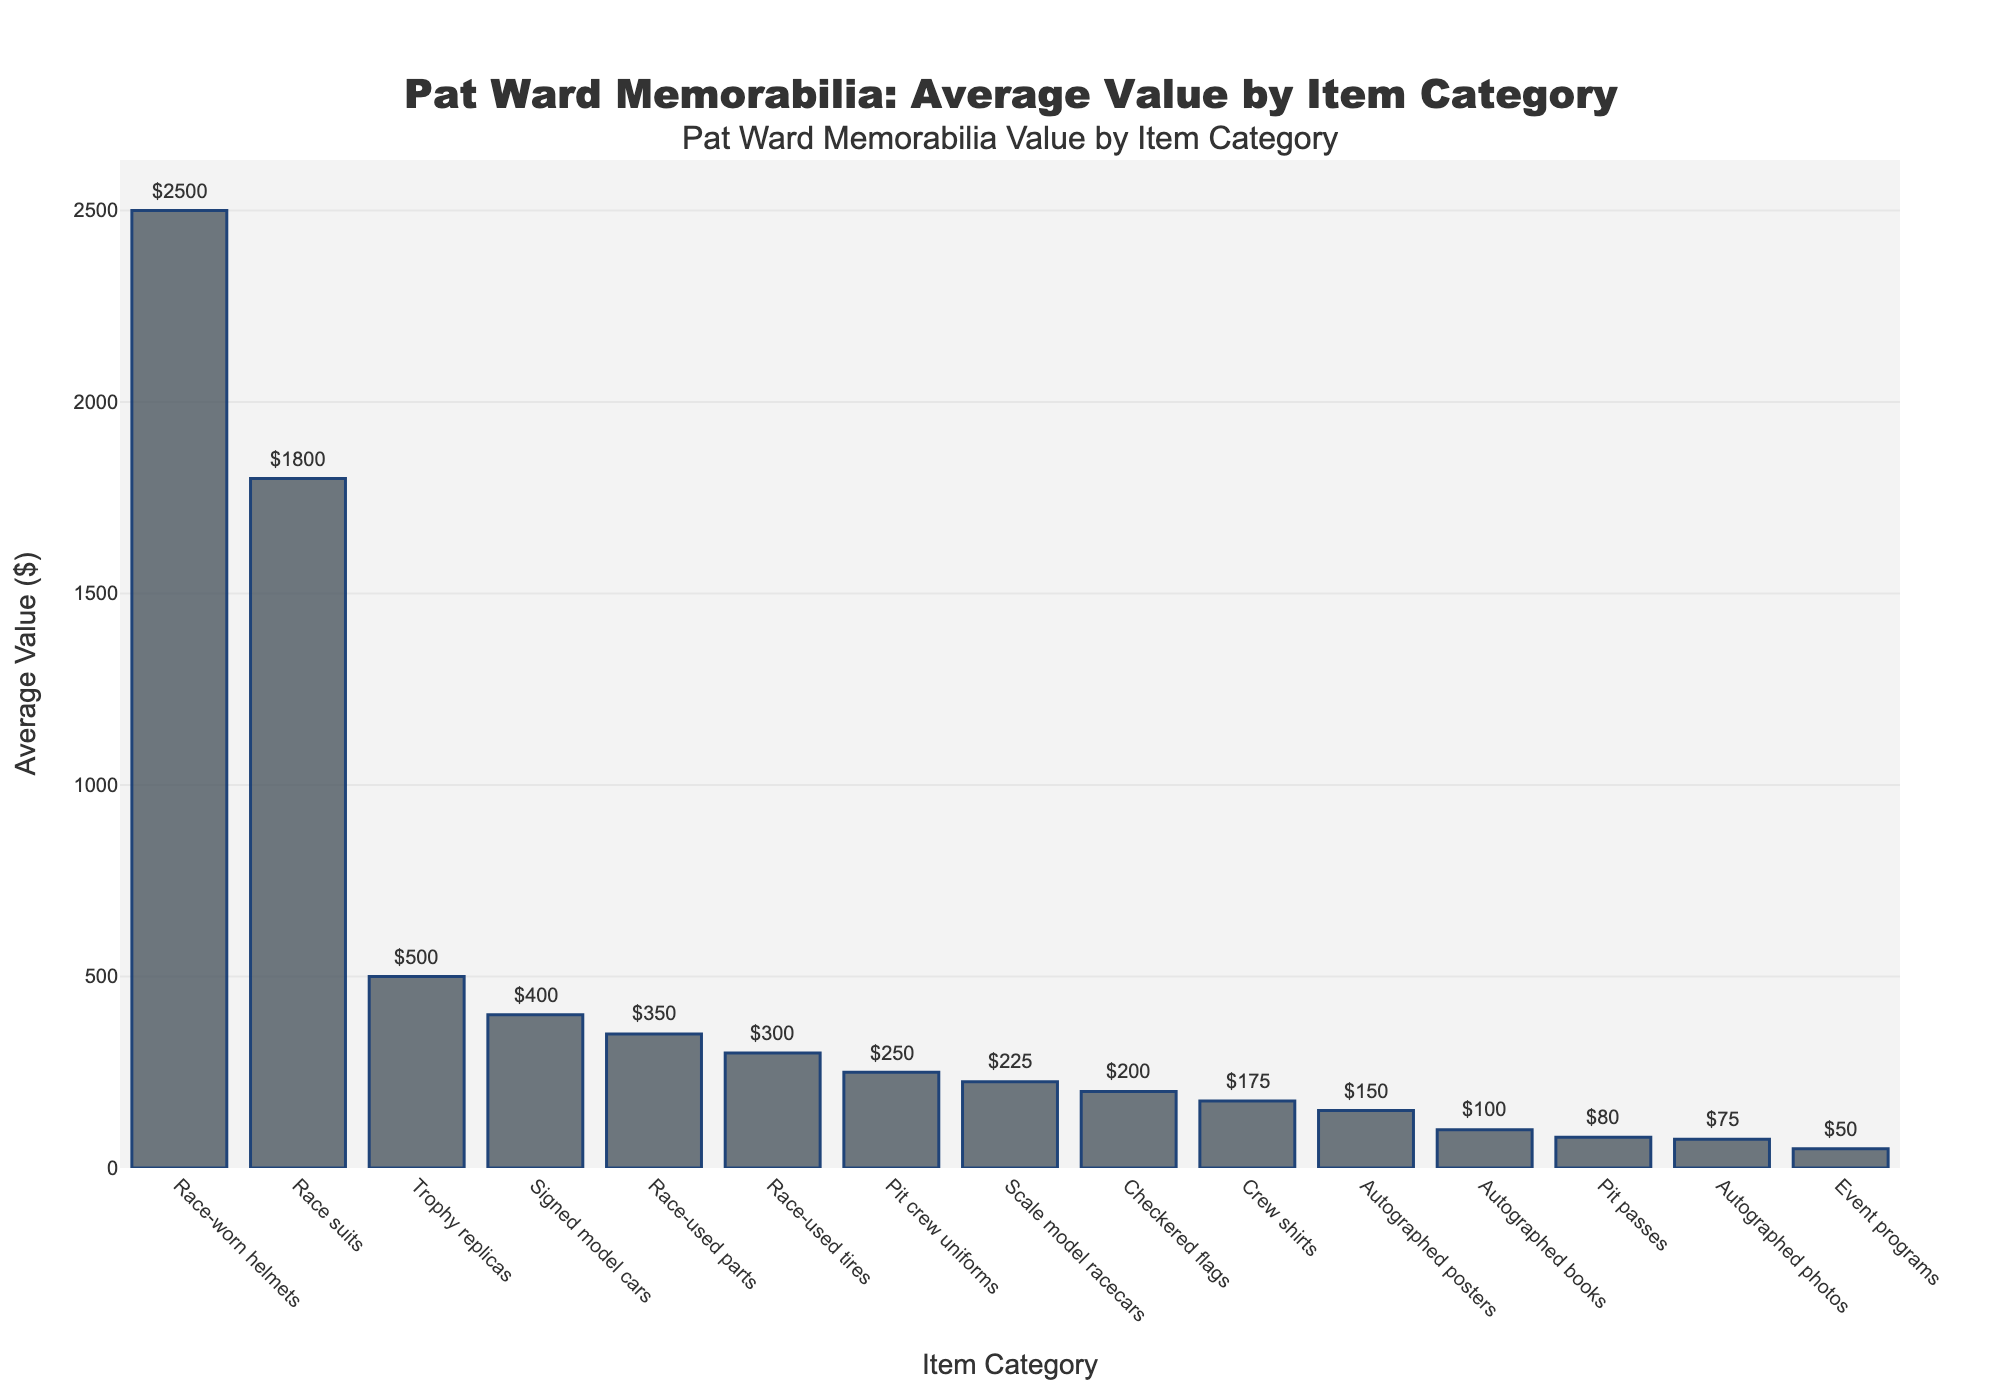Which item category has the highest average value? The highest bar represents the item with the highest average value. In this case, the "Race-worn helmets" bar is the tallest.
Answer: Race-worn helmets What is the average value of Race-used tires and Checkered flags combined? The values of "Race-used tires" and "Checkered flags" are $300 and $200, respectively. Adding them together gives 300 + 200 = 500, and dividing by 2 for the average gives 500 / 2 = 250.
Answer: 250 How many item categories have an average value above $1000? Inspect the bars that extend above the $1000 mark. "Race-worn helmets" and "Race suits" are the only ones above $1000.
Answer: 2 Which item category has an average value exactly halfway between Scale model racecars and Pit passes? The values for "Scale model racecars" and "Pit passes" are $225 and $80. The midpoint value is (225 + 80) / 2 = 152.5. The item with a value closest to $152.5 is "Autographed posters" at $150.
Answer: Autographed posters Which is greater: the sum of the average values of Race suits and Trophy replicas or the sum of the average values of Crew shirts and Autographed posters? The values for "Race suits" and "Trophy replicas" are $1800 and $500, respectively, summing to 1800 + 500 = 2300. The values for "Crew shirts" and "Autographed posters" are $175 and $150, respectively, summing to 175 + 150 = 325. 2300 is greater than 325.
Answer: Race suits and Trophy replicas Is the value of Race-used parts more than Autographed photos but less than Signed model cars? The value for "Race-used parts" is $350, for "Autographed photos" it is $75, and for "Signed model cars" it is $400. $350 is more than $75 but less than $400.
Answer: Yes What is the total average value of all item categories listed? Adding the values: 2500 + 150 + 300 + 400 + 1800 + 250 + 200 + 75 + 350 + 500 + 50 + 100 + 175 + 80 + 225. The total sum is 7155.
Answer: 7155 Are the average values of Pit crew uniforms and Crew shirts the same? The average value for "Pit crew uniforms" is $250 and for "Crew shirts" is $175. They are not the same.
Answer: No Which item category has the lowest average value and what is its value? The shortest bar represents the item with the lowest average value. This is "Event programs" at $50.
Answer: Event programs, $50 